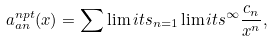<formula> <loc_0><loc_0><loc_500><loc_500>a _ { a n } ^ { n p t } ( x ) = \sum \lim i t s _ { n = 1 } \lim i t s ^ { \infty } \frac { c _ { n } } { x ^ { n } } ,</formula> 